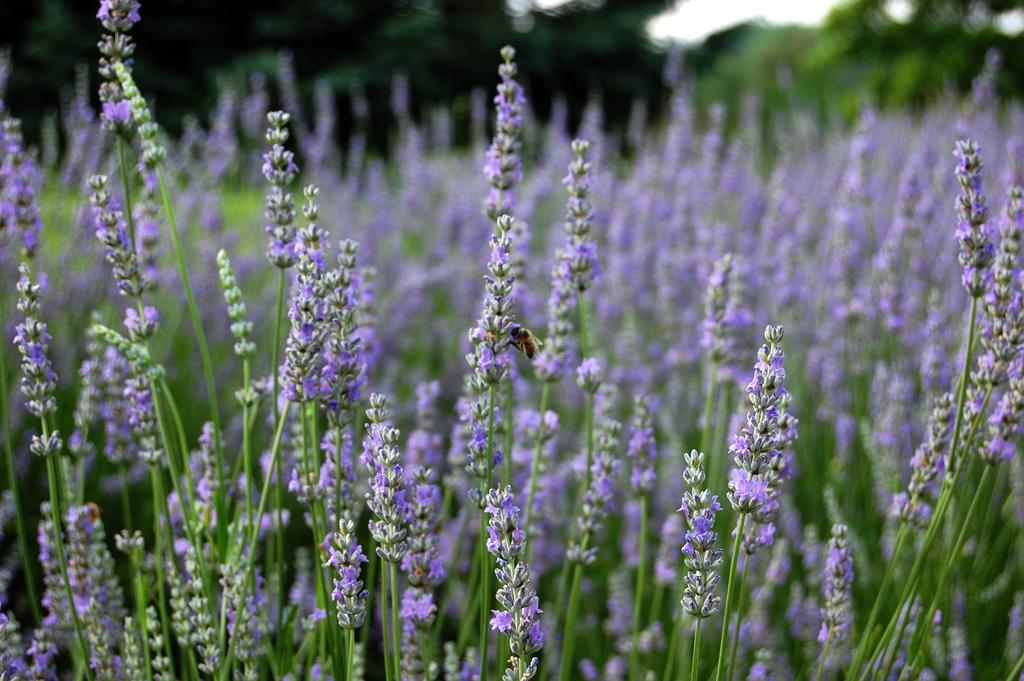What type of vegetation can be seen in the image? There are many plants in the image. Can you describe the flowers in the image? There are small flowers in blue color in the image. What insect is present in the image? There is a bee on a plant in the image. What can be seen in the background of the image? There are trees in the background of the image. What type of bait is the bee using to catch fish in the image? There is no indication in the image that the bee is trying to catch fish, nor is there any bait present. 